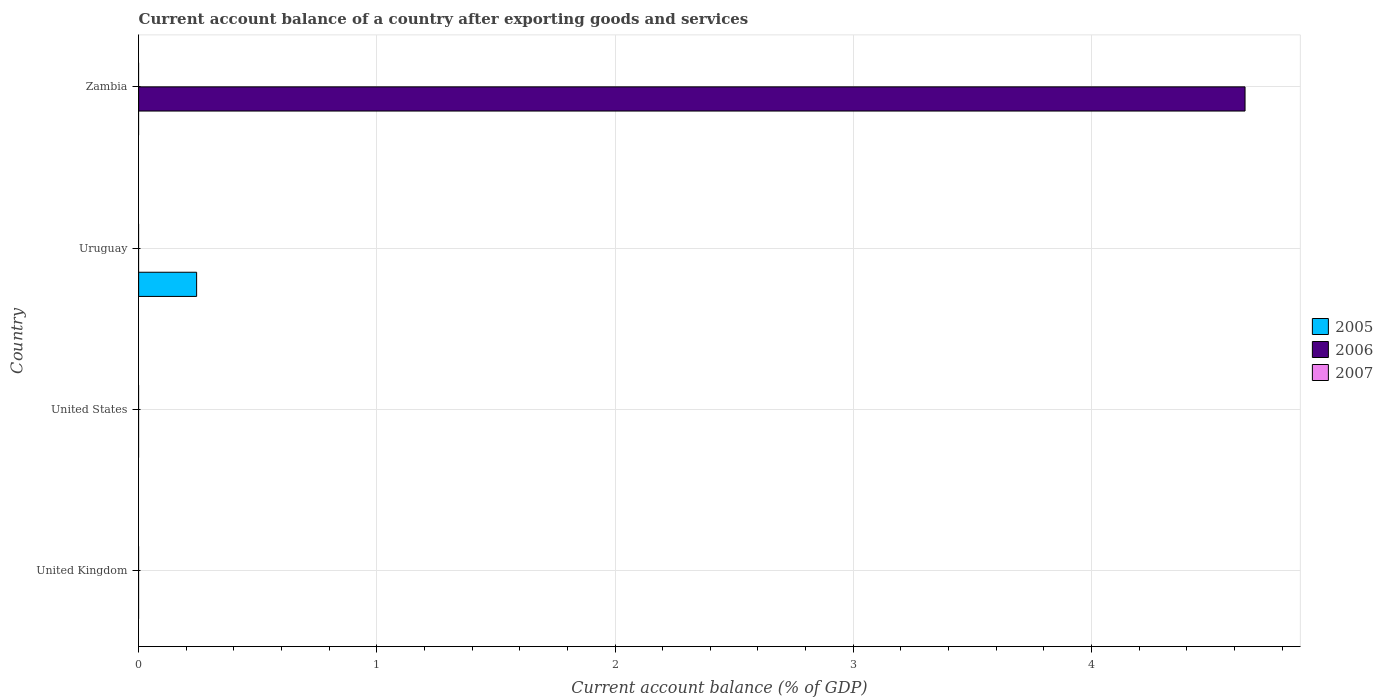Are the number of bars on each tick of the Y-axis equal?
Offer a very short reply. No. How many bars are there on the 1st tick from the top?
Give a very brief answer. 1. What is the label of the 4th group of bars from the top?
Offer a very short reply. United Kingdom. Across all countries, what is the maximum account balance in 2006?
Offer a very short reply. 4.64. Across all countries, what is the minimum account balance in 2006?
Provide a short and direct response. 0. In which country was the account balance in 2006 maximum?
Keep it short and to the point. Zambia. What is the difference between the account balance in 2007 in Uruguay and the account balance in 2005 in Zambia?
Provide a succinct answer. 0. What is the average account balance in 2006 per country?
Your answer should be very brief. 1.16. In how many countries, is the account balance in 2007 greater than 3.8 %?
Ensure brevity in your answer.  0. What is the difference between the highest and the lowest account balance in 2006?
Your answer should be very brief. 4.64. In how many countries, is the account balance in 2005 greater than the average account balance in 2005 taken over all countries?
Make the answer very short. 1. Is it the case that in every country, the sum of the account balance in 2007 and account balance in 2005 is greater than the account balance in 2006?
Provide a succinct answer. No. How many countries are there in the graph?
Offer a terse response. 4. What is the difference between two consecutive major ticks on the X-axis?
Make the answer very short. 1. Are the values on the major ticks of X-axis written in scientific E-notation?
Keep it short and to the point. No. Does the graph contain grids?
Your response must be concise. Yes. What is the title of the graph?
Make the answer very short. Current account balance of a country after exporting goods and services. What is the label or title of the X-axis?
Provide a short and direct response. Current account balance (% of GDP). What is the label or title of the Y-axis?
Keep it short and to the point. Country. What is the Current account balance (% of GDP) in 2005 in United Kingdom?
Ensure brevity in your answer.  0. What is the Current account balance (% of GDP) in 2006 in United States?
Provide a short and direct response. 0. What is the Current account balance (% of GDP) in 2007 in United States?
Give a very brief answer. 0. What is the Current account balance (% of GDP) in 2005 in Uruguay?
Your answer should be very brief. 0.24. What is the Current account balance (% of GDP) in 2006 in Uruguay?
Provide a short and direct response. 0. What is the Current account balance (% of GDP) in 2005 in Zambia?
Ensure brevity in your answer.  0. What is the Current account balance (% of GDP) in 2006 in Zambia?
Provide a succinct answer. 4.64. What is the Current account balance (% of GDP) in 2007 in Zambia?
Provide a succinct answer. 0. Across all countries, what is the maximum Current account balance (% of GDP) of 2005?
Give a very brief answer. 0.24. Across all countries, what is the maximum Current account balance (% of GDP) in 2006?
Your response must be concise. 4.64. Across all countries, what is the minimum Current account balance (% of GDP) in 2005?
Give a very brief answer. 0. What is the total Current account balance (% of GDP) of 2005 in the graph?
Make the answer very short. 0.24. What is the total Current account balance (% of GDP) of 2006 in the graph?
Your answer should be compact. 4.64. What is the difference between the Current account balance (% of GDP) in 2005 in Uruguay and the Current account balance (% of GDP) in 2006 in Zambia?
Your answer should be very brief. -4.4. What is the average Current account balance (% of GDP) of 2005 per country?
Your answer should be compact. 0.06. What is the average Current account balance (% of GDP) in 2006 per country?
Offer a very short reply. 1.16. What is the average Current account balance (% of GDP) in 2007 per country?
Your response must be concise. 0. What is the difference between the highest and the lowest Current account balance (% of GDP) in 2005?
Keep it short and to the point. 0.24. What is the difference between the highest and the lowest Current account balance (% of GDP) of 2006?
Give a very brief answer. 4.64. 